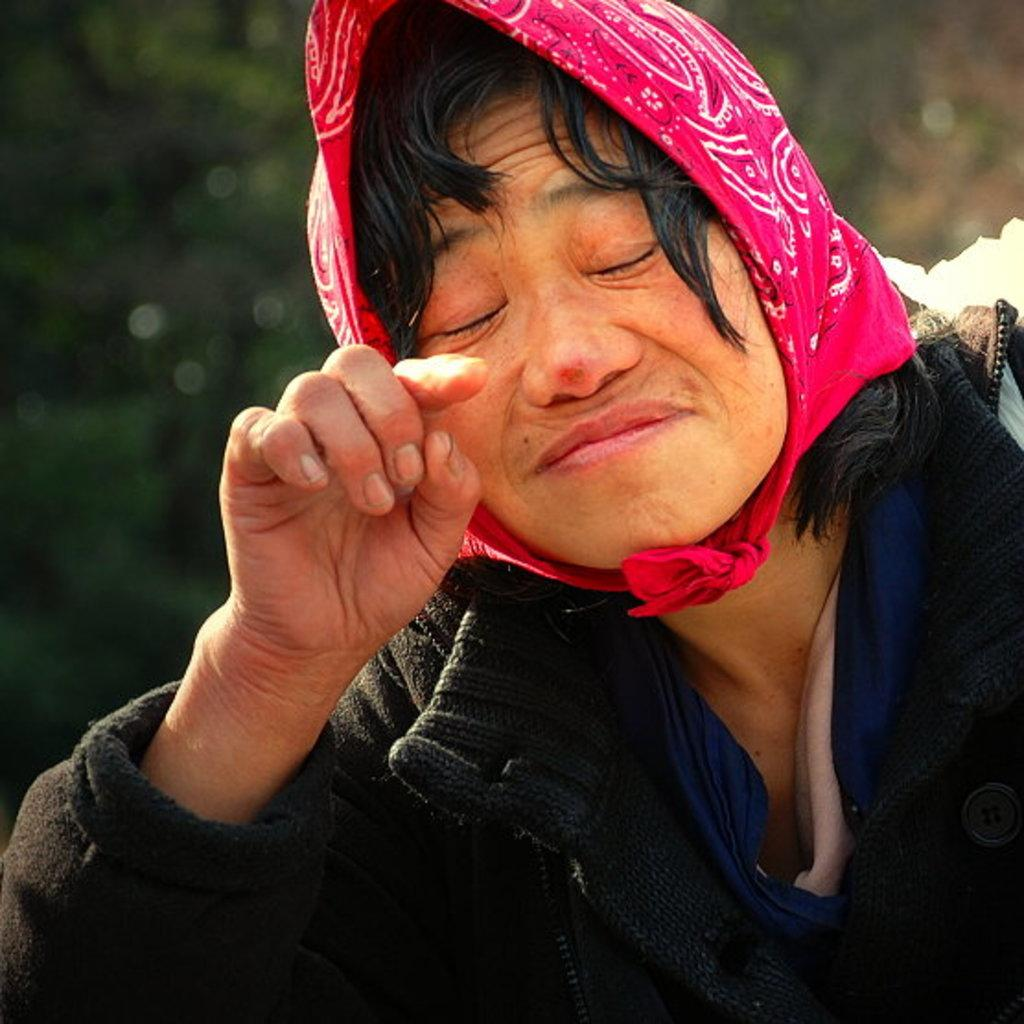Who or what is the main subject in the image? There is a person in the image. What is the person wearing? The person is wearing a black jacket. What can be seen in the background of the image? There are trees in the background of the image. How would you describe the background in the image? The background is blurred. How many dogs are visible in the image? There are no dogs present in the image. What color is the person's eye in the image? The person's eye color is not mentioned in the provided facts, so it cannot be determined from the image. 